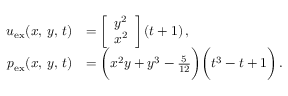Convert formula to latex. <formula><loc_0><loc_0><loc_500><loc_500>\begin{array} { r l } { u _ { e x } ( x , \, y , \, t ) } & { = \left [ \begin{array} { l } { y ^ { 2 } } \\ { x ^ { 2 } } \end{array} \right ] ( t + 1 ) \, , } \\ { p _ { e x } ( x , \, y , \, t ) } & { = \left ( x ^ { 2 } y + y ^ { 3 } - \frac { 5 } { 1 2 } \right ) \left ( t ^ { 3 } - t + 1 \right ) \, . } \end{array}</formula> 